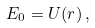Convert formula to latex. <formula><loc_0><loc_0><loc_500><loc_500>E _ { 0 } = U ( r ) \, ,</formula> 